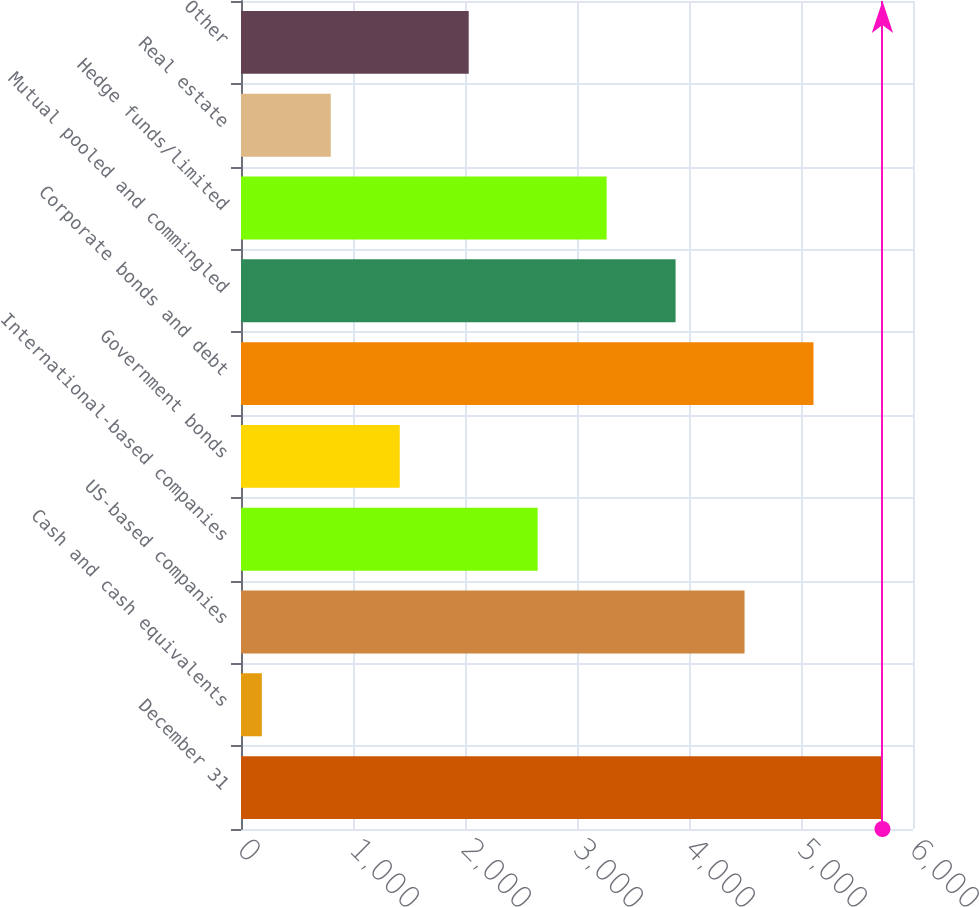Convert chart. <chart><loc_0><loc_0><loc_500><loc_500><bar_chart><fcel>December 31<fcel>Cash and cash equivalents<fcel>US-based companies<fcel>International-based companies<fcel>Government bonds<fcel>Corporate bonds and debt<fcel>Mutual pooled and commingled<fcel>Hedge funds/limited<fcel>Real estate<fcel>Other<nl><fcel>5727.3<fcel>186<fcel>4495.9<fcel>2648.8<fcel>1417.4<fcel>5111.6<fcel>3880.2<fcel>3264.5<fcel>801.7<fcel>2033.1<nl></chart> 